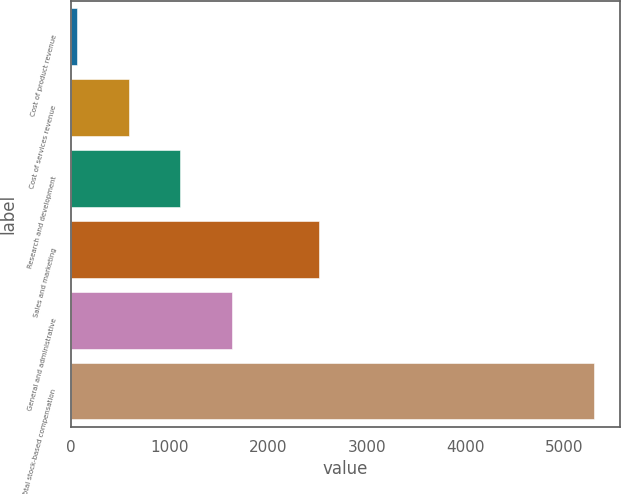Convert chart. <chart><loc_0><loc_0><loc_500><loc_500><bar_chart><fcel>Cost of product revenue<fcel>Cost of services revenue<fcel>Research and development<fcel>Sales and marketing<fcel>General and administrative<fcel>Total stock-based compensation<nl><fcel>67<fcel>590.2<fcel>1113.4<fcel>2512<fcel>1636.6<fcel>5299<nl></chart> 